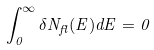Convert formula to latex. <formula><loc_0><loc_0><loc_500><loc_500>\int _ { 0 } ^ { \infty } \delta N _ { f l } ( E ) d E = 0</formula> 